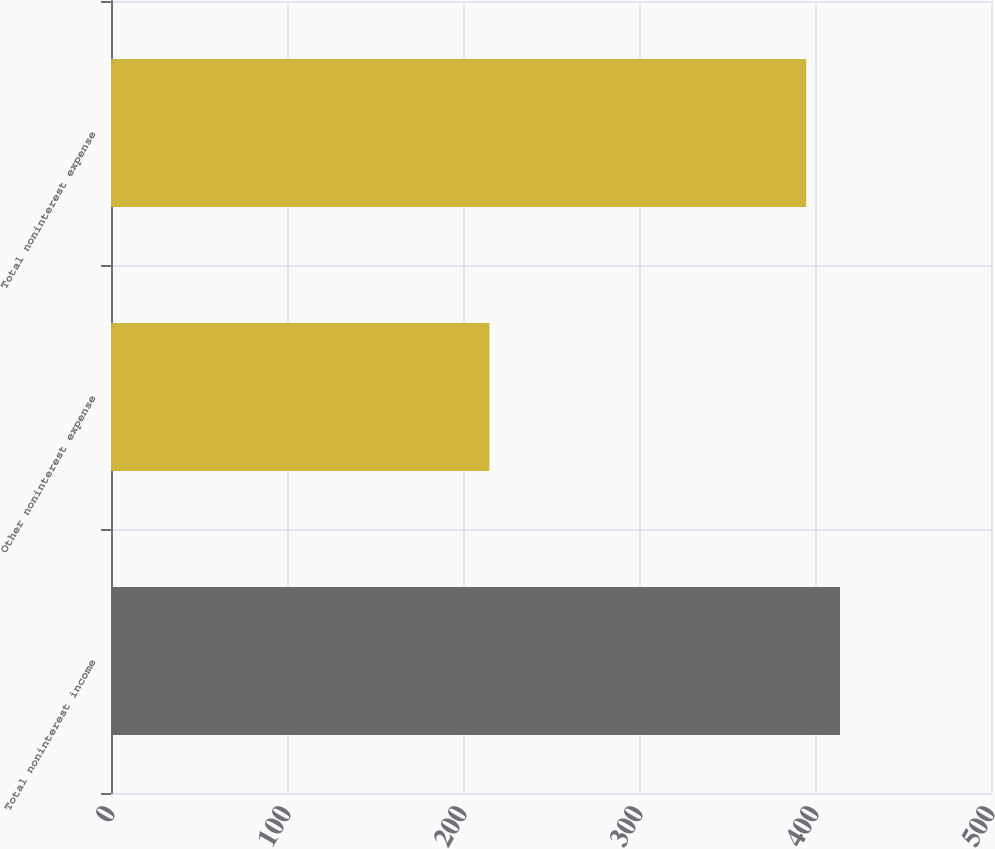Convert chart. <chart><loc_0><loc_0><loc_500><loc_500><bar_chart><fcel>Total noninterest income<fcel>Other noninterest expense<fcel>Total noninterest expense<nl><fcel>414.2<fcel>215<fcel>395<nl></chart> 